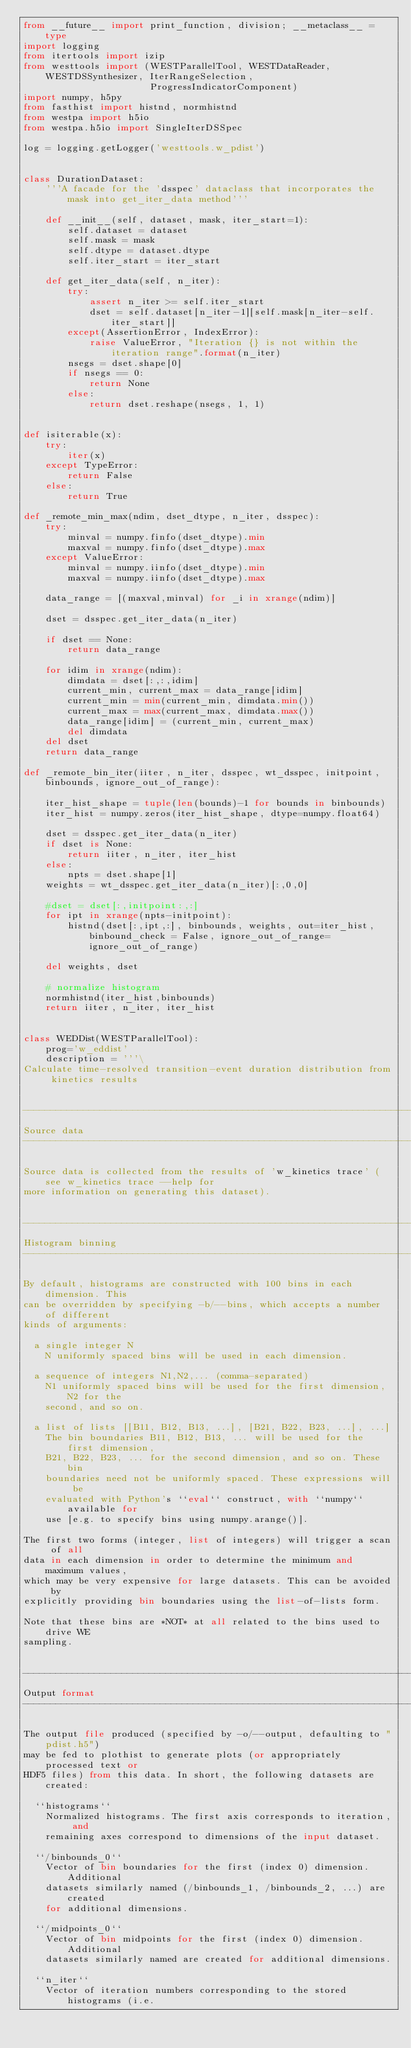Convert code to text. <code><loc_0><loc_0><loc_500><loc_500><_Python_>from __future__ import print_function, division; __metaclass__ = type
import logging
from itertools import izip
from westtools import (WESTParallelTool, WESTDataReader, WESTDSSynthesizer, IterRangeSelection, 
                       ProgressIndicatorComponent)
import numpy, h5py
from fasthist import histnd, normhistnd
from westpa import h5io
from westpa.h5io import SingleIterDSSpec

log = logging.getLogger('westtools.w_pdist')


class DurationDataset:
    '''A facade for the 'dsspec' dataclass that incorporates the mask into get_iter_data method'''

    def __init__(self, dataset, mask, iter_start=1):
        self.dataset = dataset
        self.mask = mask
        self.dtype = dataset.dtype
        self.iter_start = iter_start

    def get_iter_data(self, n_iter):
        try:
            assert n_iter >= self.iter_start
            dset = self.dataset[n_iter-1][self.mask[n_iter-self.iter_start]]
        except(AssertionError, IndexError):
            raise ValueError, "Iteration {} is not within the iteration range".format(n_iter)
        nsegs = dset.shape[0]
        if nsegs == 0:
            return None
        else:
            return dset.reshape(nsegs, 1, 1)


def isiterable(x):
    try:
        iter(x)
    except TypeError:
        return False
    else:
        return True

def _remote_min_max(ndim, dset_dtype, n_iter, dsspec):
    try:
        minval = numpy.finfo(dset_dtype).min
        maxval = numpy.finfo(dset_dtype).max
    except ValueError:
        minval = numpy.iinfo(dset_dtype).min
        maxval = numpy.iinfo(dset_dtype).max

    data_range = [(maxval,minval) for _i in xrange(ndim)]

    dset = dsspec.get_iter_data(n_iter)

    if dset == None:
        return data_range

    for idim in xrange(ndim):
        dimdata = dset[:,:,idim]
        current_min, current_max = data_range[idim]
        current_min = min(current_min, dimdata.min())
        current_max = max(current_max, dimdata.max())
        data_range[idim] = (current_min, current_max)
        del dimdata
    del dset
    return data_range

def _remote_bin_iter(iiter, n_iter, dsspec, wt_dsspec, initpoint, binbounds, ignore_out_of_range):

    iter_hist_shape = tuple(len(bounds)-1 for bounds in binbounds)
    iter_hist = numpy.zeros(iter_hist_shape, dtype=numpy.float64)

    dset = dsspec.get_iter_data(n_iter)
    if dset is None:
        return iiter, n_iter, iter_hist
    else:
        npts = dset.shape[1]
    weights = wt_dsspec.get_iter_data(n_iter)[:,0,0]

    #dset = dset[:,initpoint:,:] 
    for ipt in xrange(npts-initpoint):
        histnd(dset[:,ipt,:], binbounds, weights, out=iter_hist, binbound_check = False, ignore_out_of_range=ignore_out_of_range)

    del weights, dset

    # normalize histogram
    normhistnd(iter_hist,binbounds)
    return iiter, n_iter, iter_hist


class WEDDist(WESTParallelTool):
    prog='w_eddist'
    description = '''\
Calculate time-resolved transition-event duration distribution from kinetics results


-----------------------------------------------------------------------------
Source data
-----------------------------------------------------------------------------

Source data is collected from the results of 'w_kinetics trace' (see w_kinetics trace --help for 
more information on generating this dataset).


-----------------------------------------------------------------------------
Histogram binning
-----------------------------------------------------------------------------

By default, histograms are constructed with 100 bins in each dimension. This
can be overridden by specifying -b/--bins, which accepts a number of different
kinds of arguments:

  a single integer N
    N uniformly spaced bins will be used in each dimension.
    
  a sequence of integers N1,N2,... (comma-separated)
    N1 uniformly spaced bins will be used for the first dimension, N2 for the
    second, and so on.
    
  a list of lists [[B11, B12, B13, ...], [B21, B22, B23, ...], ...]
    The bin boundaries B11, B12, B13, ... will be used for the first dimension,
    B21, B22, B23, ... for the second dimension, and so on. These bin
    boundaries need not be uniformly spaced. These expressions will be
    evaluated with Python's ``eval`` construct, with ``numpy`` available for
    use [e.g. to specify bins using numpy.arange()].

The first two forms (integer, list of integers) will trigger a scan of all
data in each dimension in order to determine the minimum and maximum values,
which may be very expensive for large datasets. This can be avoided by
explicitly providing bin boundaries using the list-of-lists form.

Note that these bins are *NOT* at all related to the bins used to drive WE
sampling.


-----------------------------------------------------------------------------
Output format
-----------------------------------------------------------------------------

The output file produced (specified by -o/--output, defaulting to "pdist.h5")
may be fed to plothist to generate plots (or appropriately processed text or
HDF5 files) from this data. In short, the following datasets are created:

  ``histograms``
    Normalized histograms. The first axis corresponds to iteration, and
    remaining axes correspond to dimensions of the input dataset.
    
  ``/binbounds_0``
    Vector of bin boundaries for the first (index 0) dimension. Additional
    datasets similarly named (/binbounds_1, /binbounds_2, ...) are created
    for additional dimensions.
    
  ``/midpoints_0``
    Vector of bin midpoints for the first (index 0) dimension. Additional
    datasets similarly named are created for additional dimensions.
    
  ``n_iter``
    Vector of iteration numbers corresponding to the stored histograms (i.e.</code> 